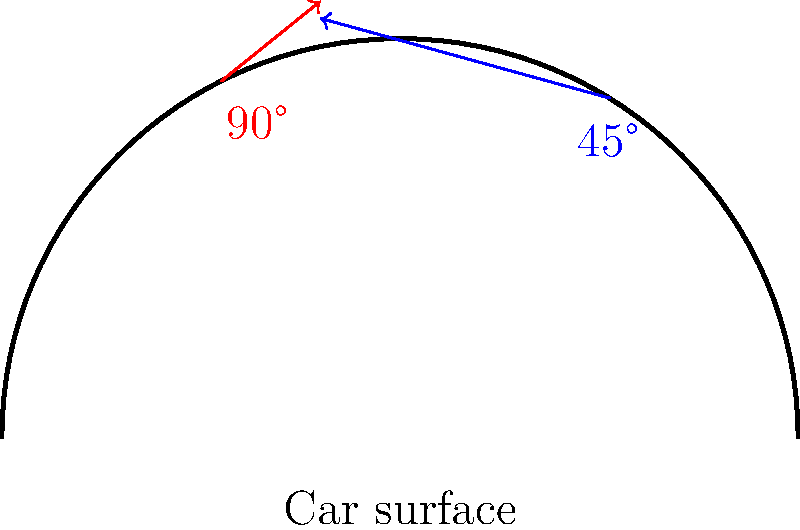As a vehicle customization expert, you're tasked with painting a curved car surface. Given the diagram showing two spray angles (45° and 90°), which angle would provide more even paint coverage on the curved surface, and why? To determine the optimal spray angle for even paint coverage on a curved car surface, we need to consider several factors:

1. Surface normal: The ideal spray angle should be as close to perpendicular to the surface normal as possible at each point.

2. Paint droplet distribution: A wider spray angle typically results in a more even distribution of paint droplets.

3. Overspray: Extreme angles can lead to excessive overspray, wasting paint and potentially causing uneven coverage.

4. Coverage area: The spray angle affects the area covered by each pass, influencing efficiency and evenness.

In this case:

1. 45° angle:
   - Provides a more consistent angle relative to the surface normal across the curve.
   - Reduces overspray compared to wider angles.
   - Allows for better control and precision.

2. 90° angle:
   - Perpendicular only at the top of the curve.
   - Creates more overspray at the sides.
   - Covers a larger area but with less consistency.

The 45° angle would provide more even coverage because:
a) It maintains a more consistent angle relative to the surface normal across the entire curve.
b) It reduces overspray, especially on the sides of the curved surface.
c) It allows for better control and precision during application.

While the 90° angle might cover a larger area faster, it would result in uneven coverage due to the varying distance and angle from the spray nozzle to different parts of the curved surface.
Answer: 45° angle 